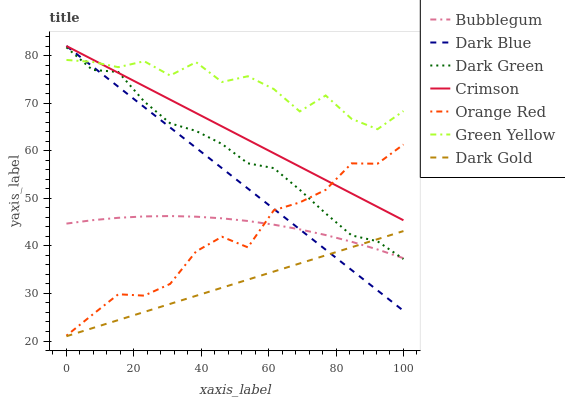Does Dark Gold have the minimum area under the curve?
Answer yes or no. Yes. Does Green Yellow have the maximum area under the curve?
Answer yes or no. Yes. Does Bubblegum have the minimum area under the curve?
Answer yes or no. No. Does Bubblegum have the maximum area under the curve?
Answer yes or no. No. Is Dark Gold the smoothest?
Answer yes or no. Yes. Is Green Yellow the roughest?
Answer yes or no. Yes. Is Bubblegum the smoothest?
Answer yes or no. No. Is Bubblegum the roughest?
Answer yes or no. No. Does Dark Gold have the lowest value?
Answer yes or no. Yes. Does Bubblegum have the lowest value?
Answer yes or no. No. Does Crimson have the highest value?
Answer yes or no. Yes. Does Bubblegum have the highest value?
Answer yes or no. No. Is Bubblegum less than Crimson?
Answer yes or no. Yes. Is Green Yellow greater than Bubblegum?
Answer yes or no. Yes. Does Dark Green intersect Orange Red?
Answer yes or no. Yes. Is Dark Green less than Orange Red?
Answer yes or no. No. Is Dark Green greater than Orange Red?
Answer yes or no. No. Does Bubblegum intersect Crimson?
Answer yes or no. No. 